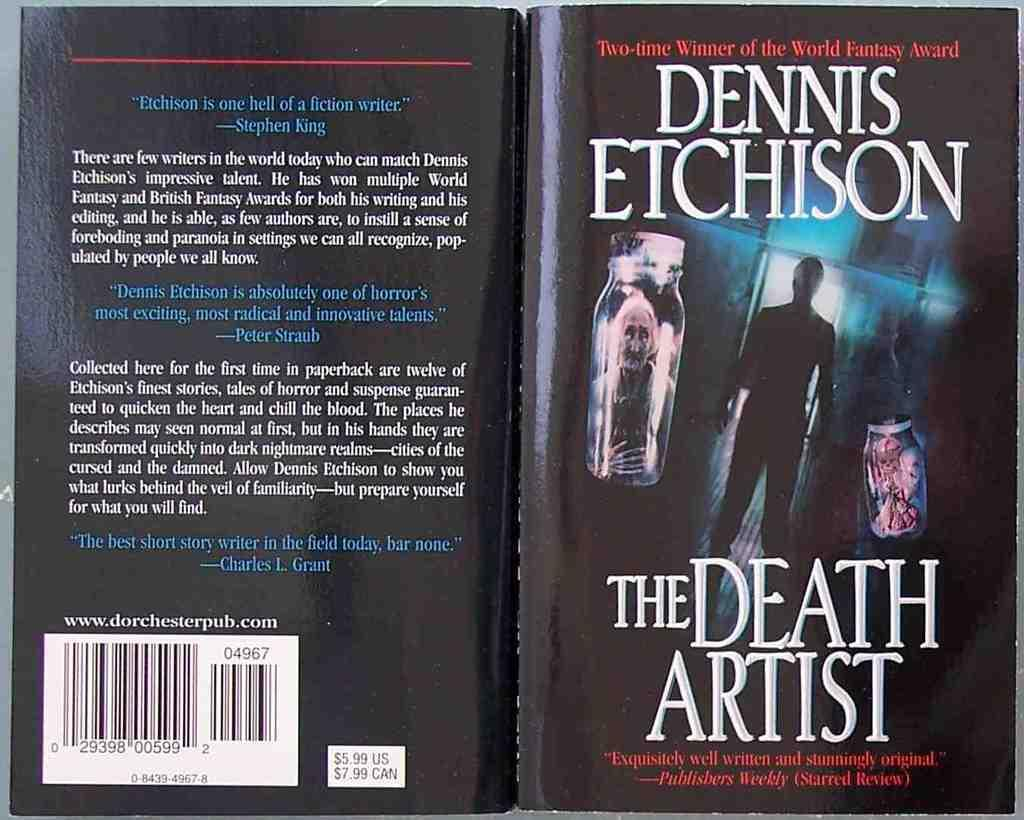<image>
Share a concise interpretation of the image provided. Cover and back for  The Death Artist by Dennis etchinson showing a dark figure of a man. 